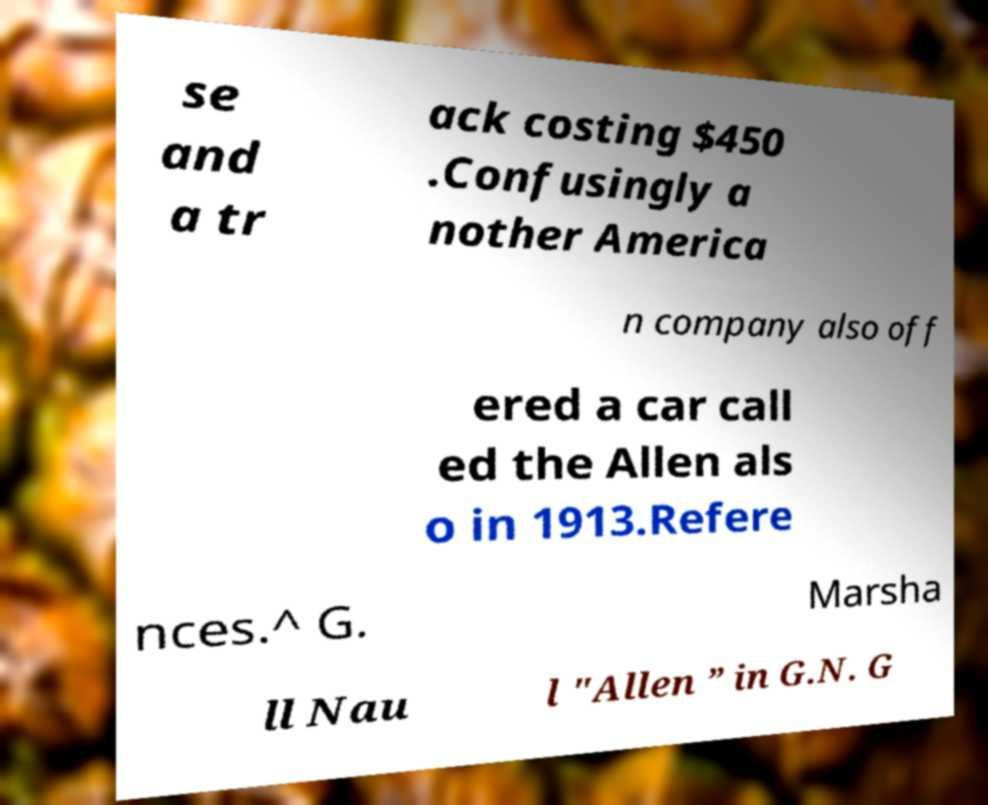Can you accurately transcribe the text from the provided image for me? se and a tr ack costing $450 .Confusingly a nother America n company also off ered a car call ed the Allen als o in 1913.Refere nces.^ G. Marsha ll Nau l "Allen ” in G.N. G 